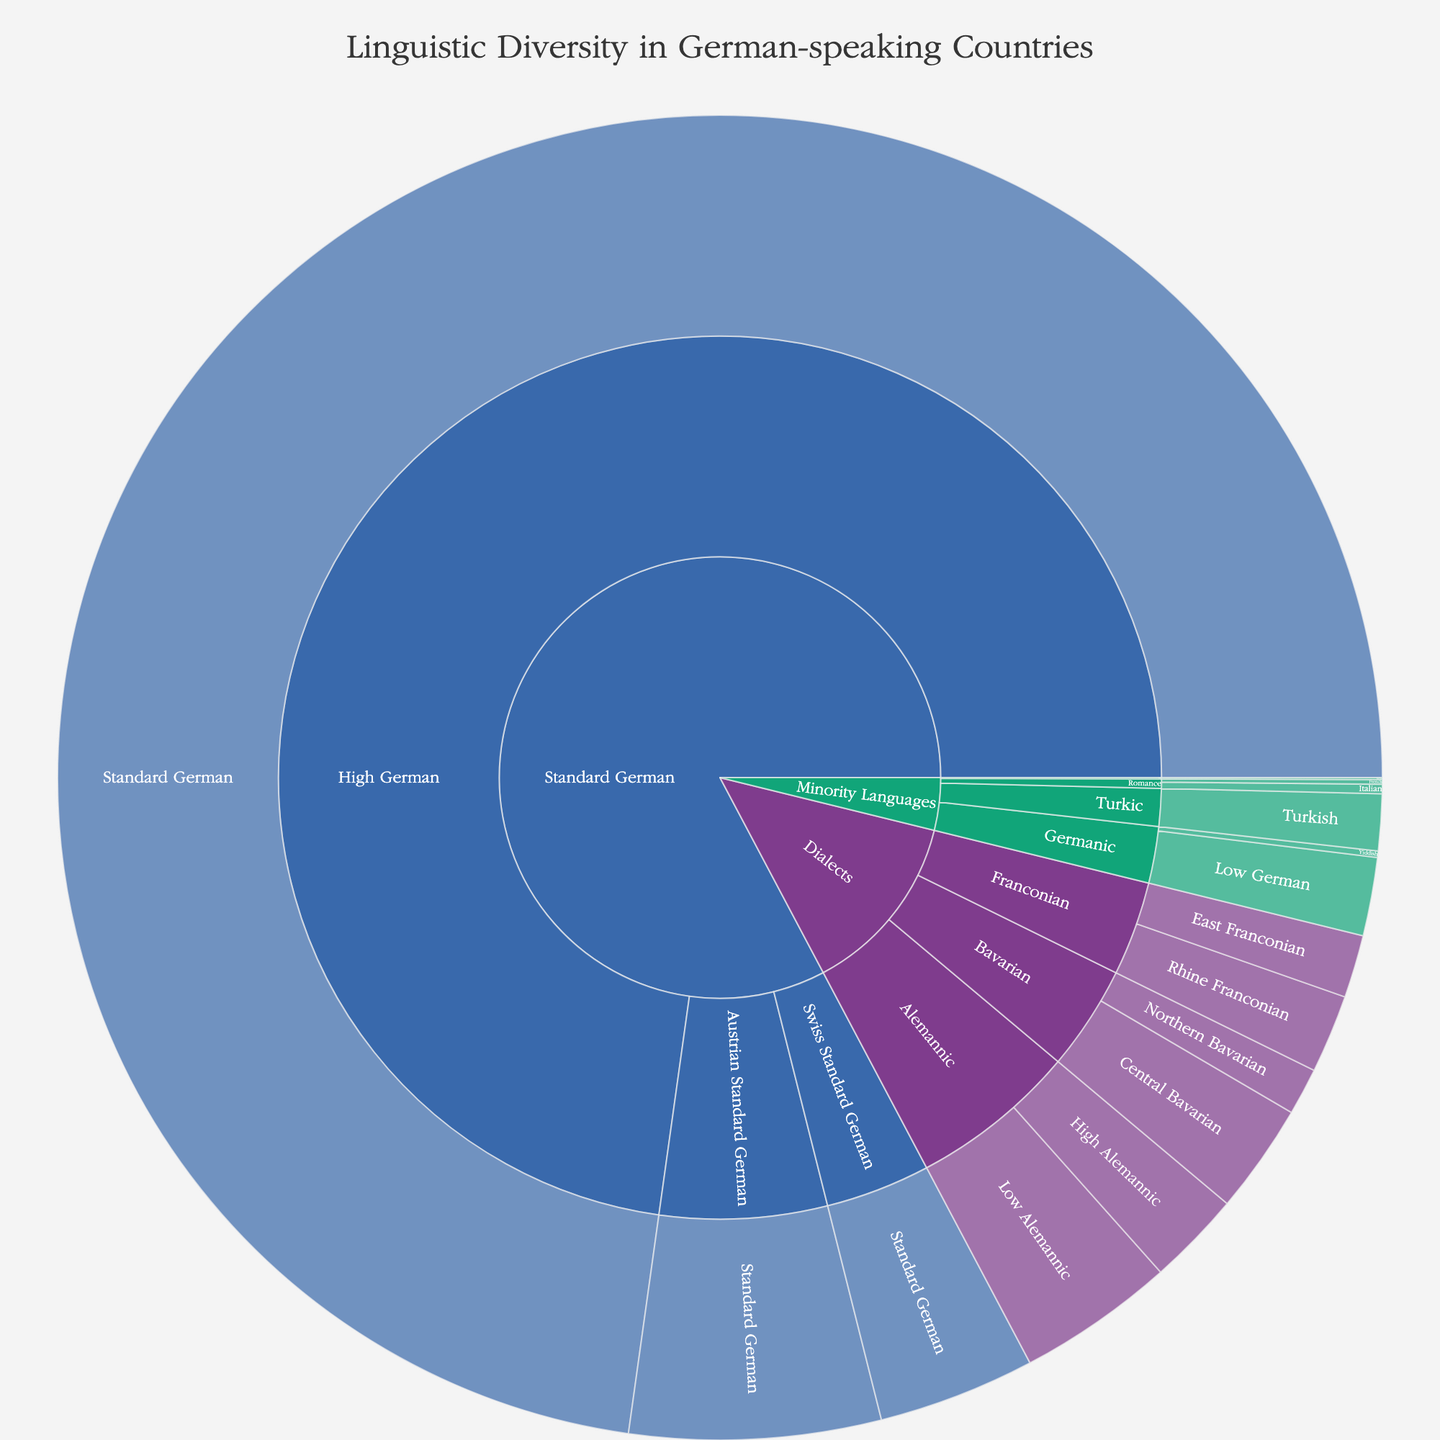what is the total number of speakers of Standard German, Swiss Standard German, and Austrian Standard German combined? To find the total number of speakers for these languages, look at the segments labeled "Standard German", "Swiss Standard German", and "Austrian Standard German". Sum up their speaker counts: 95,000,000 + 5,000,000 + 8,000,000 = 108,000,000.
Answer: 108,000,000 What is the total number of speakers for all languages in the 'Dialects' category? To find this, sum up the speaker counts for all segments under 'Dialects': Low Alemannic (5,000,000), High Alemannic (3,000,000), Northern Bavarian (1,500,000), Central Bavarian (3,500,000), East Franconian (2,000,000), Rhine Franconian (2,500,000). This results in 5,000,000 + 3,000,000 + 1,500,000 + 3,500,000 + 2,000,000 + 2,500,000 = 17,500,000.
Answer: 17,500,000 Which dialect under the Alemannic subcategory has more speakers, Low Alemannic or High Alemannic? Compare the numbers of speakers: Low Alemannic has 5,000,000 speakers and High Alemannic has 3,000,000 speakers. Low Alemannic has more speakers.
Answer: Low Alemannic How does the number of speakers of the Turkish language compare to those of Low German within the Minority Languages category? Look at the two segments within the Minority Languages category. The Turkish language has 1,800,000 speakers, while Low German has 2,500,000 speakers. Therefore, Turkish has fewer speakers compared to Low German.
Answer: Turkish has fewer speakers What is the ratio of Standard German speakers to the total number of speakers in the 'Minority Languages' category? First, sum the speakers in the 'Minority Languages': Low German (2,500,000), Yiddish (200,000), Sorbian (60,000), Italian (300,000), French (150,000), Turkish (1,800,000). This totals 2,500,000 + 200,000 + 60,000 + 300,000 + 150,000 + 1,800,000 = 5,010,000. Now, find the ratio: Standard German speakers (95,000,000) / total Minority Languages speakers (5,010,000) = 95,000,000 / 5,010,000 ≈ 18.96.
Answer: Approximately 18.96 Which subcategory has the fewest speakers within the 'Minority Languages' category? Look at all the segments under 'Minority Languages': Germanic (2,500,000 for Low German, 200,000 for Yiddish), Slavic (60,000 for Sorbian), Romance (300,000 for Italian, 150,000 for French), Turkic (1,800,000 for Turkish). The Slavic subcategory, with 60,000 speakers, has the fewest speakers.
Answer: Slavic What's the proportion of speakers of Angela dialects to the total number of speakers in the 'Dialects' category? Angela dialects include Low Alemannic (5,000,000) and High Alemannic (3,000,000) speakers, totaling 8,000,000. The total of 'Dialects' speakers is 17,500,000. The proportion is 8,000,000 / 17,500,000 ≈ 0.457, or approximately 45.7%.
Answer: Approximately 45.7% Which has more speakers, the entire 'Franconian' subcategory or the 'Central Bavarian' dialect? Look at segments under 'Franconian': East Franconian (2,000,000), Rhine Franconian (2,500,000), totaling 4,500,000. 'Central Bavarian' has 3,500,000 speakers. Therefore, the 'Franconian' subcategory has more speakers.
Answer: Franconian What is the difference between the number of speakers of Standard German and all the other languages combined? First, sum all speakers excluding Standard German: 108,000,000 (total for Standard, Swiss, and Austrian Standard German) + 17,500,000 (Dialects) + 5,010,000 (Minority Languages) = 25,010,000. Subtract this from the total for Standard German: 95,000,000 - 25,010,000 = 69,990,000.
Answer: 69,990,000 